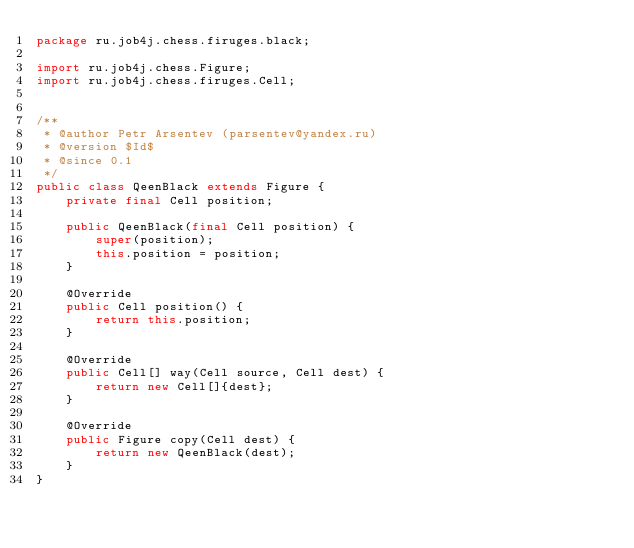Convert code to text. <code><loc_0><loc_0><loc_500><loc_500><_Java_>package ru.job4j.chess.firuges.black;

import ru.job4j.chess.Figure;
import ru.job4j.chess.firuges.Cell;


/**
 * @author Petr Arsentev (parsentev@yandex.ru)
 * @version $Id$
 * @since 0.1
 */
public class QeenBlack extends Figure {
    private final Cell position;

    public QeenBlack(final Cell position) {
        super(position);
        this.position = position;
    }

    @Override
    public Cell position() {
        return this.position;
    }

    @Override
    public Cell[] way(Cell source, Cell dest) {
        return new Cell[]{dest};
    }

    @Override
    public Figure copy(Cell dest) {
        return new QeenBlack(dest);
    }
}
</code> 